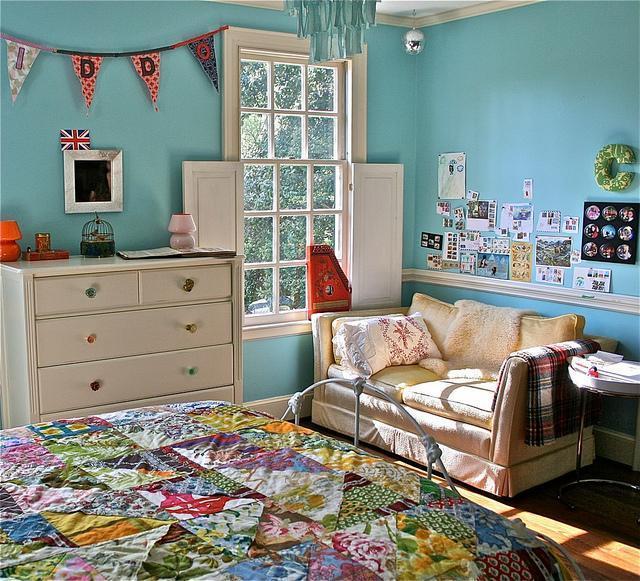How many drawers are there?
Give a very brief answer. 5. 